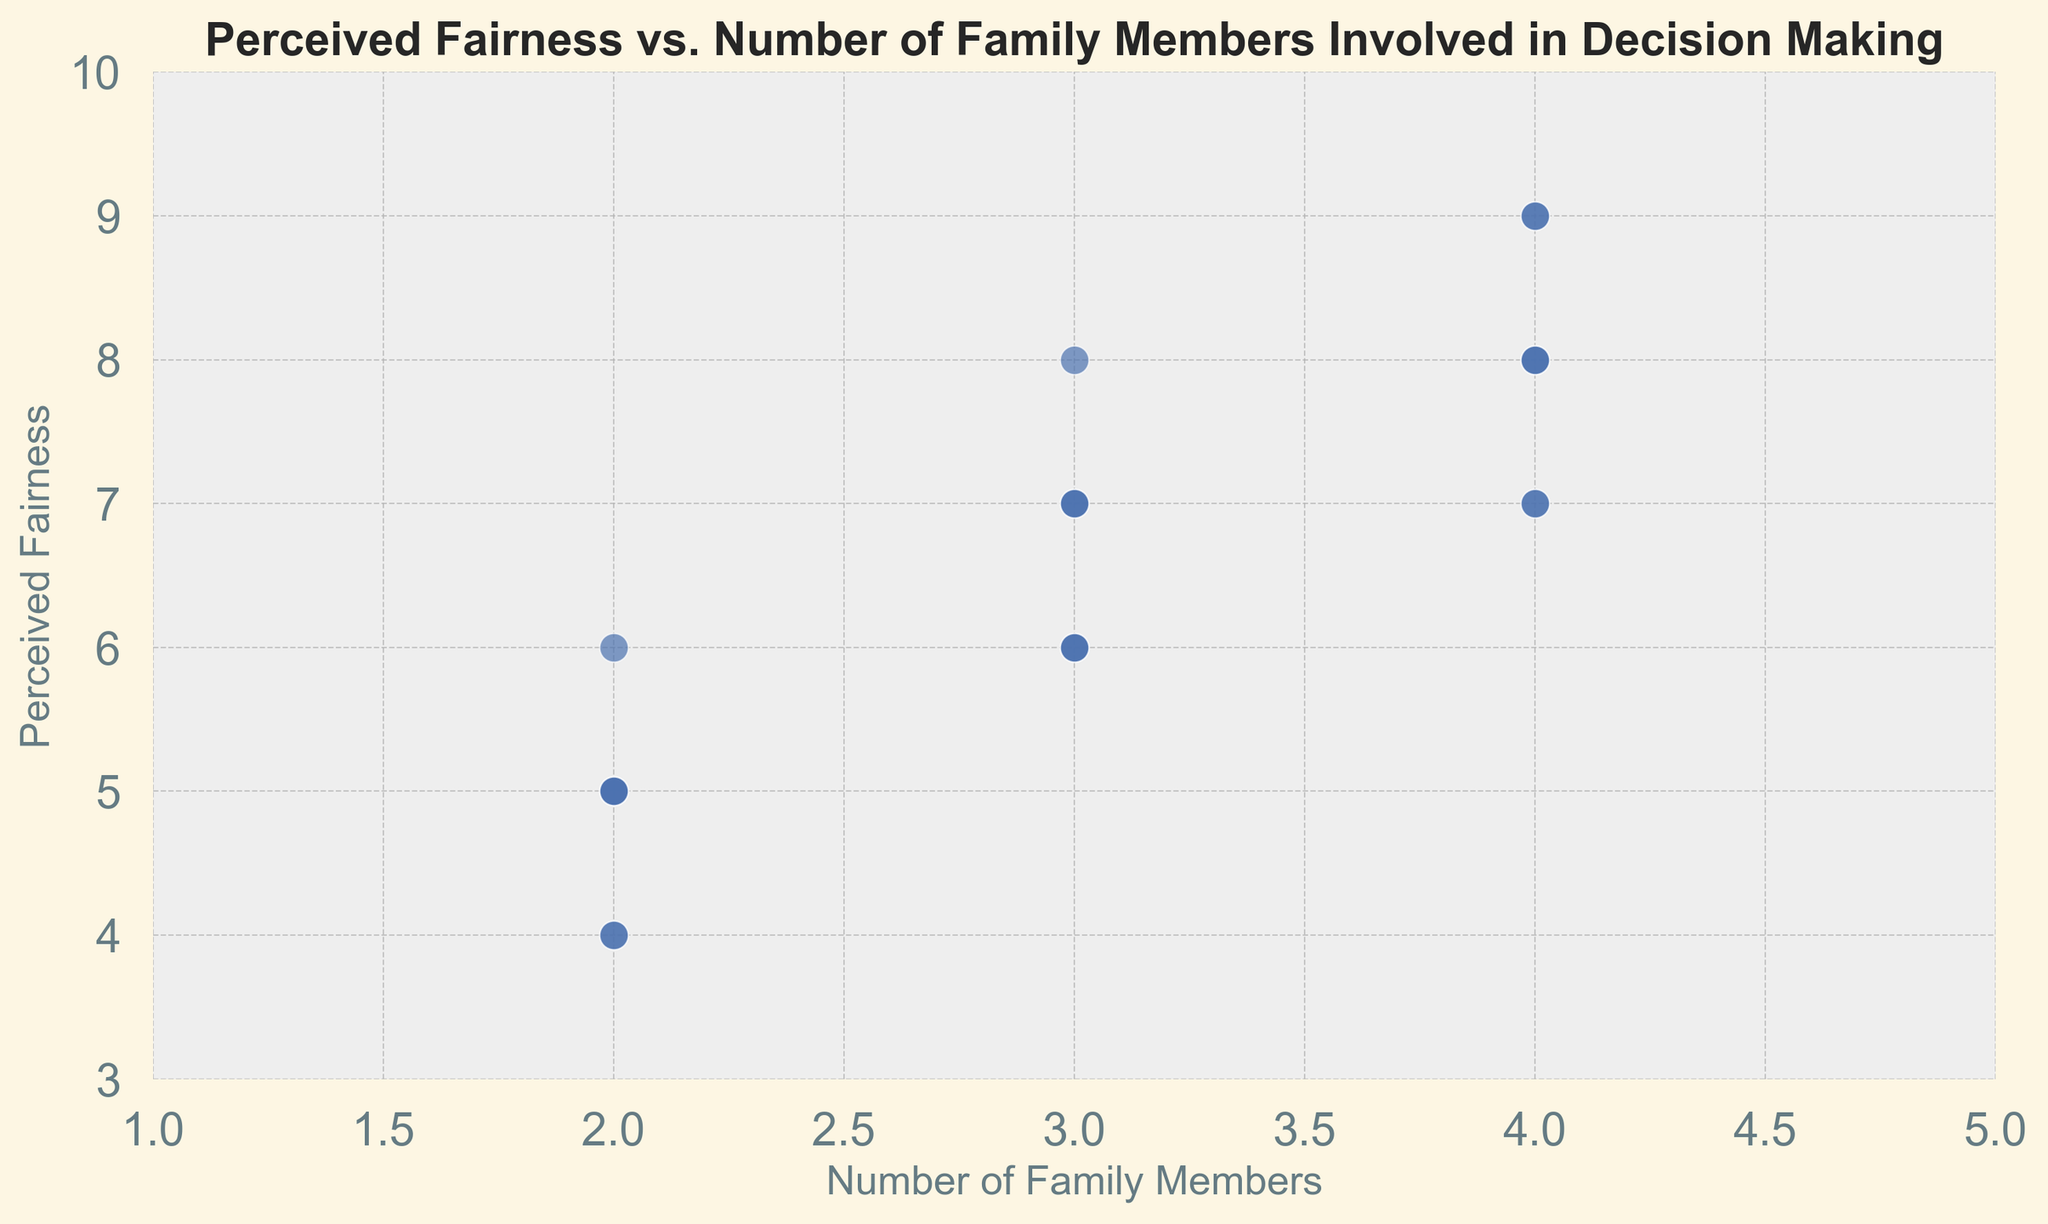What's the average perceived fairness when 4 family members are involved in decision making? The points for 4 family members are (8, 7, 8, 9, 7, 9, 8). Summing these values gives 56. Dividing by 7 points gives an average of 8.
Answer: 8 Is the perceived fairness higher with 3 or 4 family members involved in decision making? The data shows perceived fairness ranging from 6 to 9 for 4 family members, and from 6 to 8 for 3 family members. The highest perceived fairness values for 4 family members are higher than those for 3.
Answer: 4 family members What is the range of perceived fairness scores when there are 2 family members involved in decision making? The lowest perceived fairness score with 2 family members is 4 and the highest is 6. The range is 6 - 4 = 2.
Answer: 2 How many data points indicate a perceived fairness of 7? By counting the dots on the scatter plot for perceived fairness = 7, we see six points: three with 3 family members and three with 4 family members.
Answer: 6 What is the median perceived fairness score for the data points with 2 family members? The perceived fairness scores for 2 family members are (6, 5, 4, 5, 5, 4, 5). Sorting these gives (4, 4, 5, 5, 5, 5, 6). The middle value (4th value) is 5.
Answer: 5 Which group has the lowest perceived fairness score? Perceived fairness is lowest (4) when 2 family members are involved, which does not occur in other groups.
Answer: 2 family members What is the correlation between the number of family members involved and perceived fairness? Visually, as the number of family members involved increases, the perceived fairness generally increases as well. This suggests a positive correlation.
Answer: Positive correlation How often does perceived fairness score reach 9? Perceived fairness of 9 occurs twice for 4 family members, and doesn't appear for other groups.
Answer: 2 times 